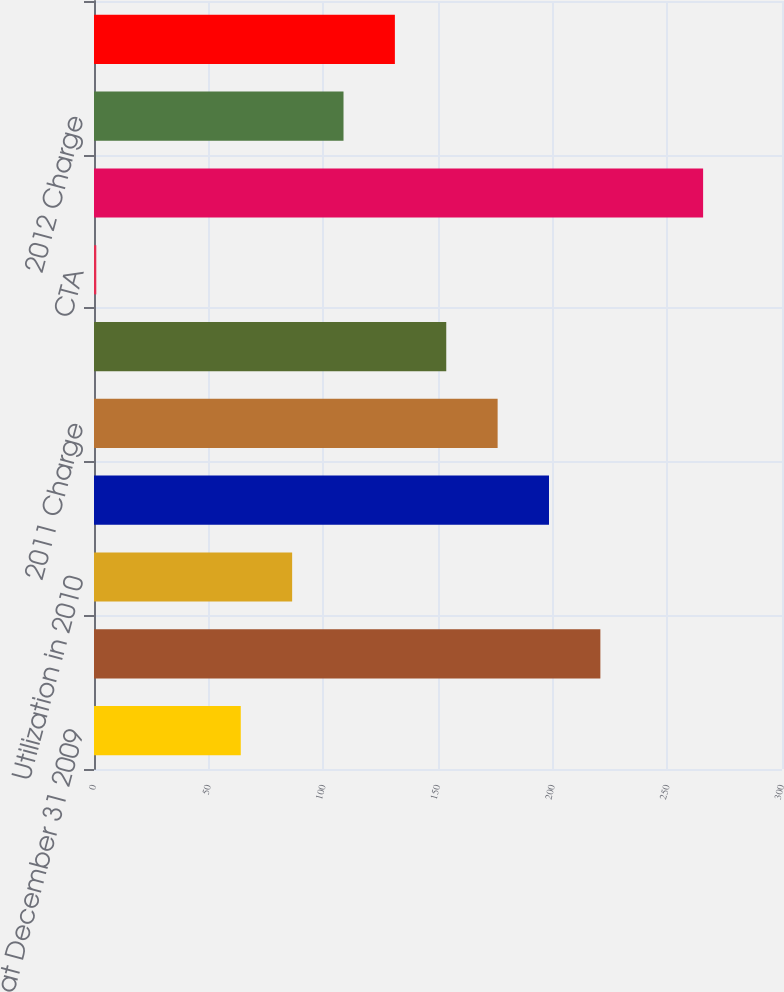Convert chart. <chart><loc_0><loc_0><loc_500><loc_500><bar_chart><fcel>Reserve at December 31 2009<fcel>2010 Charge<fcel>Utilization in 2010<fcel>Reserve at December 31 2010<fcel>2011 Charge<fcel>Utilization in 2011<fcel>CTA<fcel>Reserve at December 31 2011<fcel>2012 Charge<fcel>Utilization in 2012<nl><fcel>64<fcel>220.8<fcel>86.4<fcel>198.4<fcel>176<fcel>153.6<fcel>1<fcel>265.6<fcel>108.8<fcel>131.2<nl></chart> 